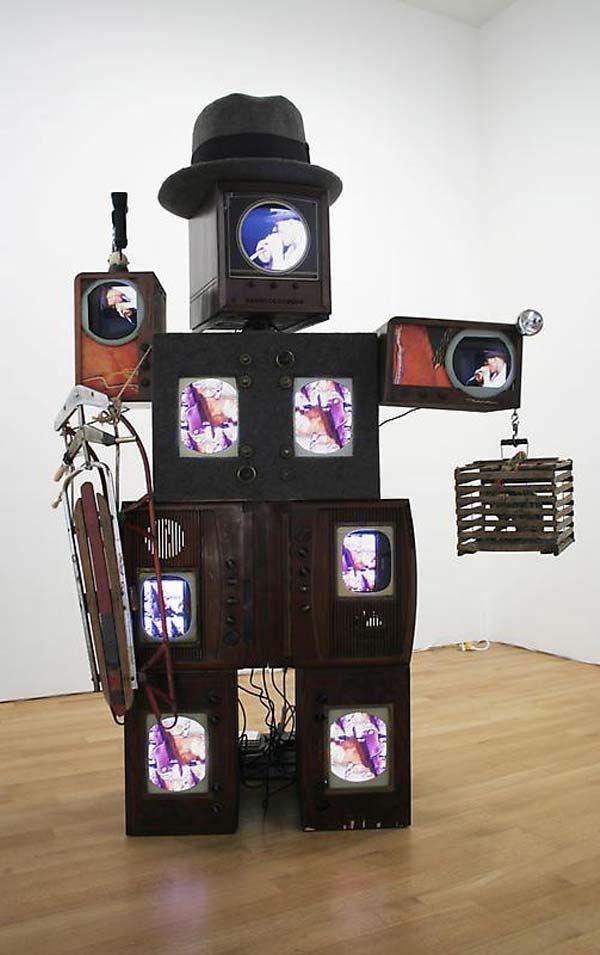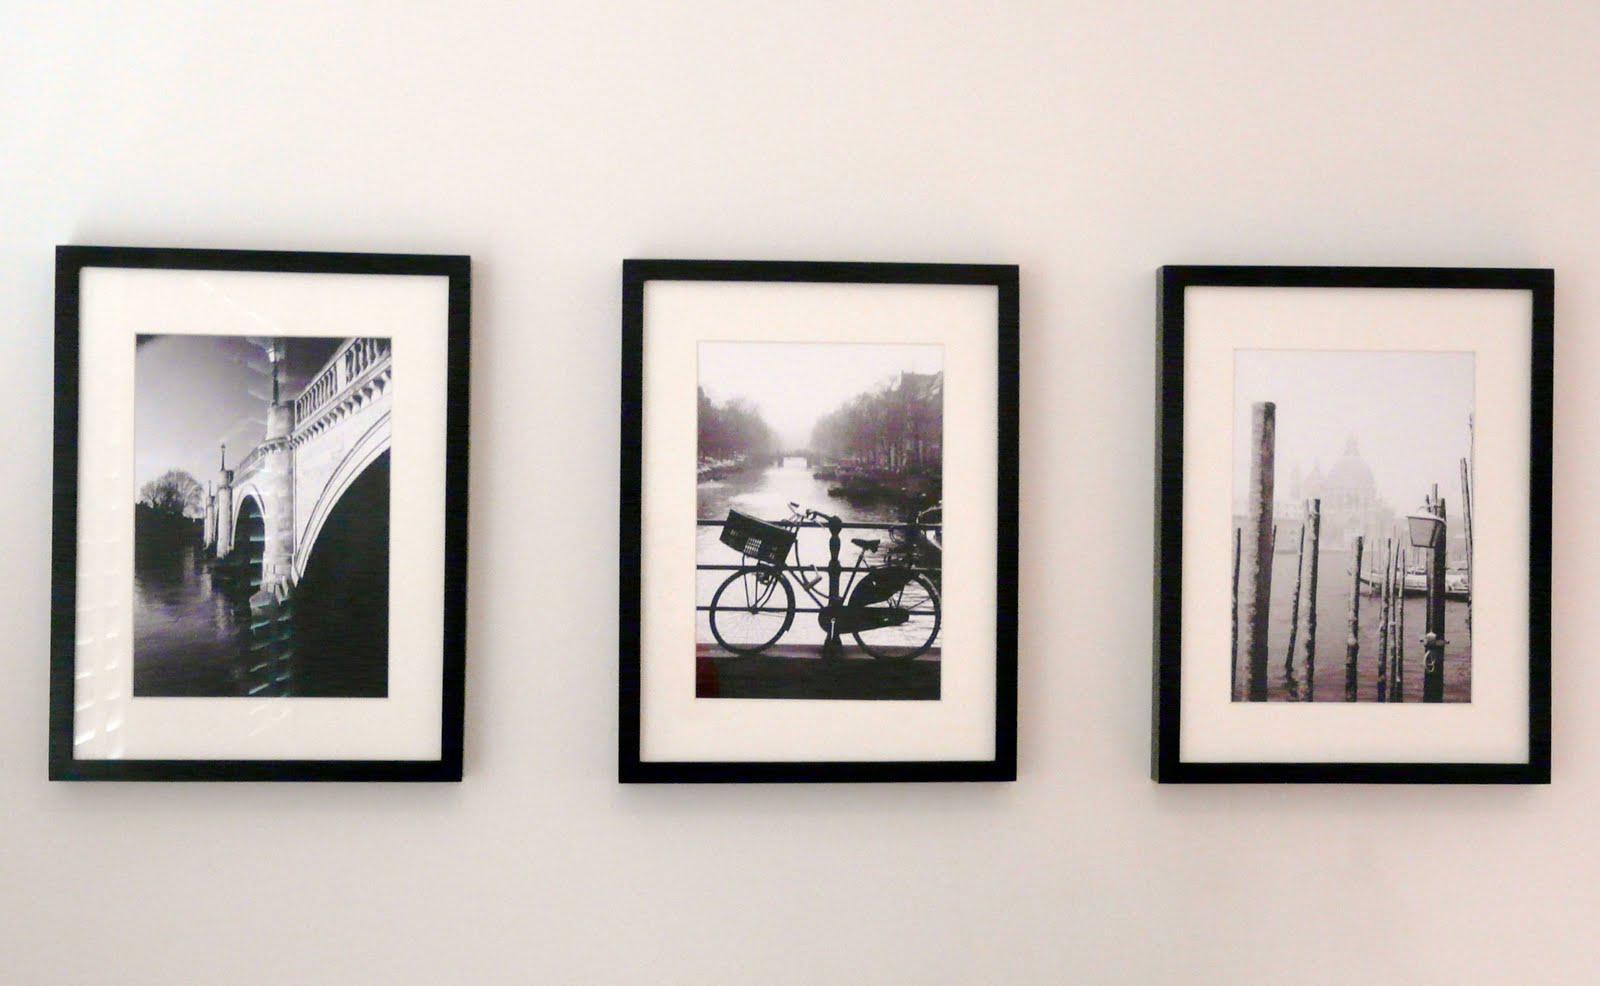The first image is the image on the left, the second image is the image on the right. Analyze the images presented: Is the assertion "Stacked cubes with screens take the shape of an animate object in one image." valid? Answer yes or no. Yes. The first image is the image on the left, the second image is the image on the right. Analyze the images presented: Is the assertion "A sculpture resembling a lifeform is made from televisions in one of the images." valid? Answer yes or no. Yes. 